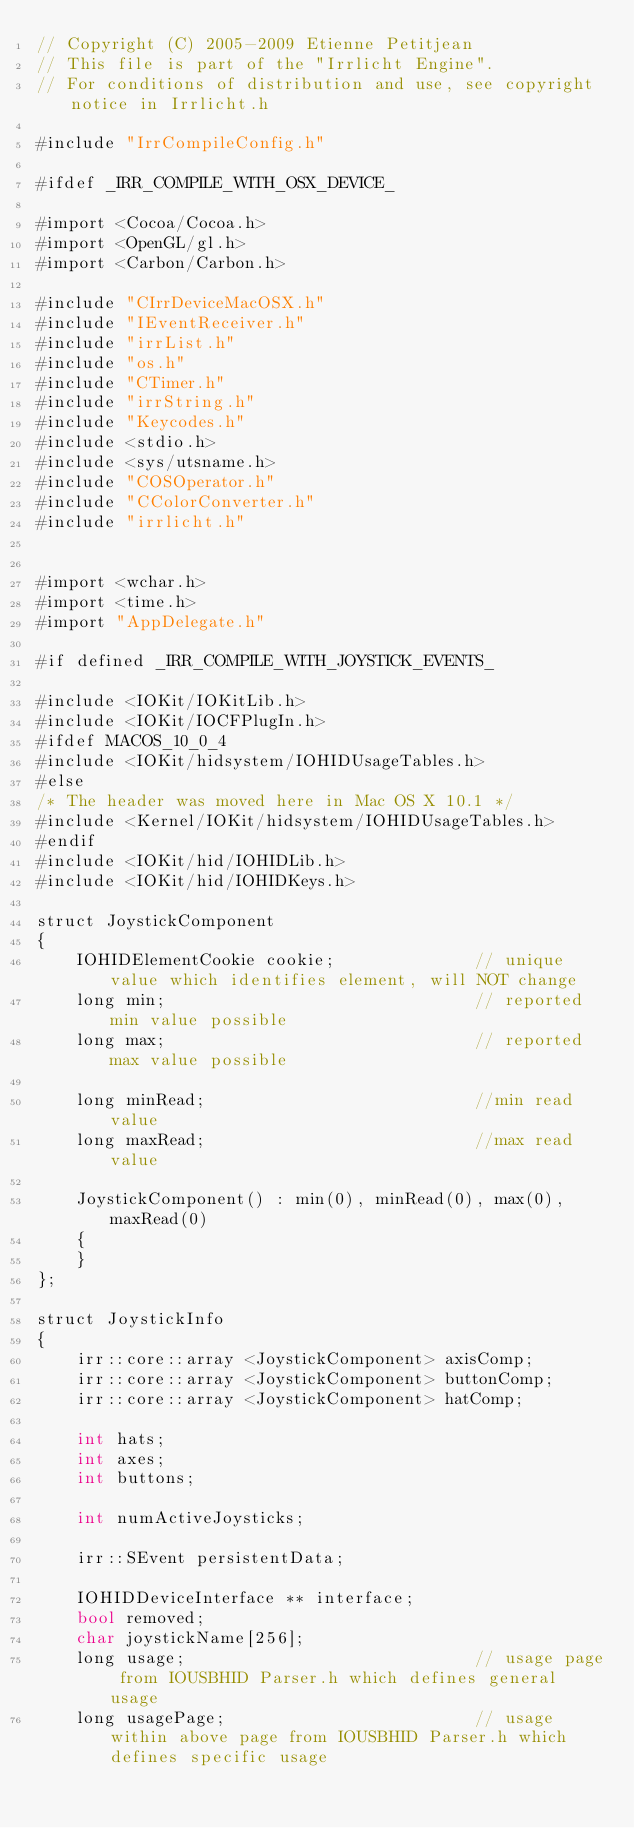<code> <loc_0><loc_0><loc_500><loc_500><_ObjectiveC_>// Copyright (C) 2005-2009 Etienne Petitjean
// This file is part of the "Irrlicht Engine".
// For conditions of distribution and use, see copyright notice in Irrlicht.h

#include "IrrCompileConfig.h"

#ifdef _IRR_COMPILE_WITH_OSX_DEVICE_

#import <Cocoa/Cocoa.h>
#import <OpenGL/gl.h>
#import <Carbon/Carbon.h>

#include "CIrrDeviceMacOSX.h"
#include "IEventReceiver.h"
#include "irrList.h"
#include "os.h"
#include "CTimer.h"
#include "irrString.h"
#include "Keycodes.h"
#include <stdio.h>
#include <sys/utsname.h>
#include "COSOperator.h"
#include "CColorConverter.h"
#include "irrlicht.h"


#import <wchar.h>
#import <time.h>
#import "AppDelegate.h"

#if defined _IRR_COMPILE_WITH_JOYSTICK_EVENTS_

#include <IOKit/IOKitLib.h>
#include <IOKit/IOCFPlugIn.h>
#ifdef MACOS_10_0_4
#include <IOKit/hidsystem/IOHIDUsageTables.h>
#else
/* The header was moved here in Mac OS X 10.1 */
#include <Kernel/IOKit/hidsystem/IOHIDUsageTables.h>
#endif
#include <IOKit/hid/IOHIDLib.h>
#include <IOKit/hid/IOHIDKeys.h>

struct JoystickComponent
{
	IOHIDElementCookie cookie;				// unique value which identifies element, will NOT change
	long min;								// reported min value possible
	long max;								// reported max value possible

	long minRead;							//min read value
	long maxRead;							//max read value

	JoystickComponent() : min(0), minRead(0), max(0), maxRead(0)
	{
	}
};

struct JoystickInfo
{
	irr::core::array <JoystickComponent> axisComp;
	irr::core::array <JoystickComponent> buttonComp;
	irr::core::array <JoystickComponent> hatComp;

	int	hats;
	int	axes;
	int	buttons;

	int numActiveJoysticks;

	irr::SEvent persistentData;

	IOHIDDeviceInterface ** interface;
	bool removed;
	char joystickName[256];
	long usage;								// usage page from IOUSBHID Parser.h which defines general usage
	long usagePage;							// usage within above page from IOUSBHID Parser.h which defines specific usage
</code> 